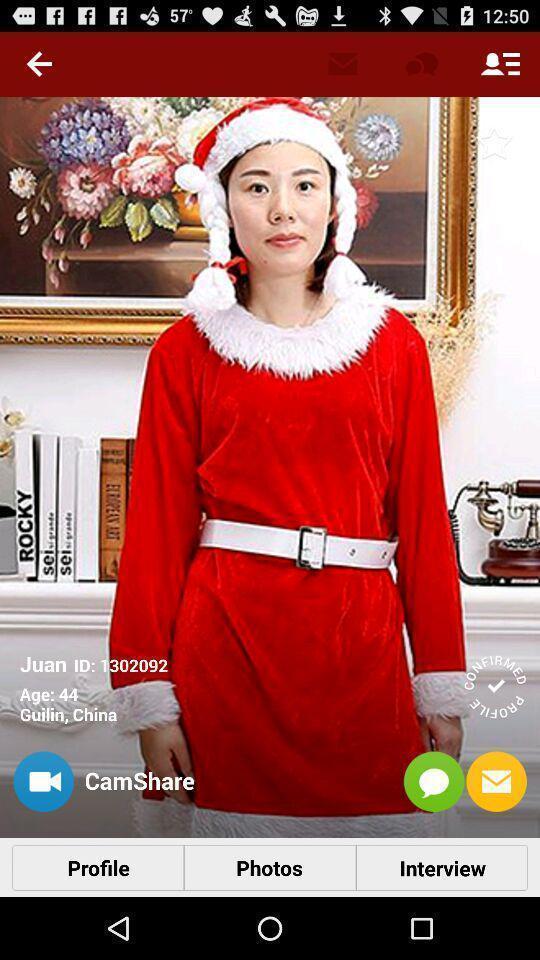Tell me what you see in this picture. Profile details displaying in this page. 